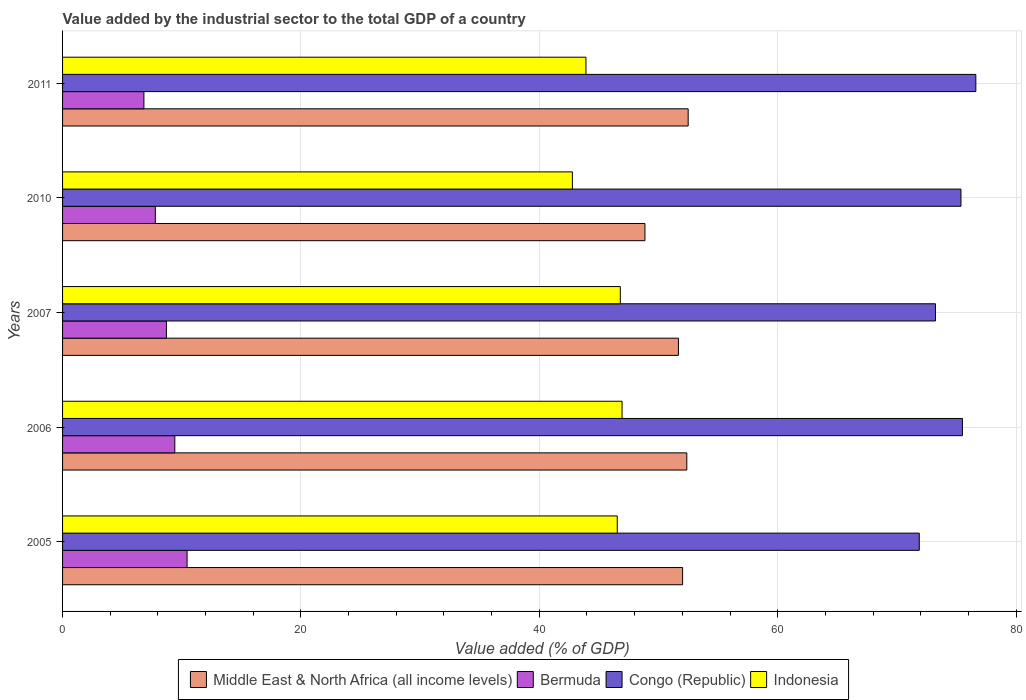How many different coloured bars are there?
Your answer should be compact. 4. How many bars are there on the 3rd tick from the top?
Your answer should be compact. 4. What is the label of the 5th group of bars from the top?
Your response must be concise. 2005. In how many cases, is the number of bars for a given year not equal to the number of legend labels?
Ensure brevity in your answer.  0. What is the value added by the industrial sector to the total GDP in Bermuda in 2006?
Provide a short and direct response. 9.42. Across all years, what is the maximum value added by the industrial sector to the total GDP in Indonesia?
Your answer should be compact. 46.94. Across all years, what is the minimum value added by the industrial sector to the total GDP in Indonesia?
Keep it short and to the point. 42.78. What is the total value added by the industrial sector to the total GDP in Middle East & North Africa (all income levels) in the graph?
Make the answer very short. 257.42. What is the difference between the value added by the industrial sector to the total GDP in Indonesia in 2005 and that in 2011?
Offer a very short reply. 2.63. What is the difference between the value added by the industrial sector to the total GDP in Middle East & North Africa (all income levels) in 2006 and the value added by the industrial sector to the total GDP in Indonesia in 2011?
Offer a very short reply. 8.46. What is the average value added by the industrial sector to the total GDP in Middle East & North Africa (all income levels) per year?
Keep it short and to the point. 51.48. In the year 2010, what is the difference between the value added by the industrial sector to the total GDP in Indonesia and value added by the industrial sector to the total GDP in Bermuda?
Ensure brevity in your answer.  34.99. In how many years, is the value added by the industrial sector to the total GDP in Congo (Republic) greater than 24 %?
Ensure brevity in your answer.  5. What is the ratio of the value added by the industrial sector to the total GDP in Bermuda in 2005 to that in 2007?
Your answer should be compact. 1.2. Is the difference between the value added by the industrial sector to the total GDP in Indonesia in 2006 and 2007 greater than the difference between the value added by the industrial sector to the total GDP in Bermuda in 2006 and 2007?
Your response must be concise. No. What is the difference between the highest and the second highest value added by the industrial sector to the total GDP in Indonesia?
Make the answer very short. 0.14. What is the difference between the highest and the lowest value added by the industrial sector to the total GDP in Middle East & North Africa (all income levels)?
Keep it short and to the point. 3.63. In how many years, is the value added by the industrial sector to the total GDP in Congo (Republic) greater than the average value added by the industrial sector to the total GDP in Congo (Republic) taken over all years?
Provide a succinct answer. 3. Is the sum of the value added by the industrial sector to the total GDP in Indonesia in 2007 and 2011 greater than the maximum value added by the industrial sector to the total GDP in Bermuda across all years?
Keep it short and to the point. Yes. Is it the case that in every year, the sum of the value added by the industrial sector to the total GDP in Bermuda and value added by the industrial sector to the total GDP in Congo (Republic) is greater than the sum of value added by the industrial sector to the total GDP in Middle East & North Africa (all income levels) and value added by the industrial sector to the total GDP in Indonesia?
Make the answer very short. Yes. What does the 3rd bar from the top in 2006 represents?
Offer a terse response. Bermuda. What does the 4th bar from the bottom in 2011 represents?
Make the answer very short. Indonesia. How many bars are there?
Offer a very short reply. 20. How many years are there in the graph?
Give a very brief answer. 5. What is the difference between two consecutive major ticks on the X-axis?
Ensure brevity in your answer.  20. Are the values on the major ticks of X-axis written in scientific E-notation?
Provide a short and direct response. No. How are the legend labels stacked?
Give a very brief answer. Horizontal. What is the title of the graph?
Offer a very short reply. Value added by the industrial sector to the total GDP of a country. What is the label or title of the X-axis?
Offer a terse response. Value added (% of GDP). What is the label or title of the Y-axis?
Provide a short and direct response. Years. What is the Value added (% of GDP) of Middle East & North Africa (all income levels) in 2005?
Provide a short and direct response. 52.02. What is the Value added (% of GDP) in Bermuda in 2005?
Ensure brevity in your answer.  10.45. What is the Value added (% of GDP) of Congo (Republic) in 2005?
Your answer should be compact. 71.88. What is the Value added (% of GDP) of Indonesia in 2005?
Keep it short and to the point. 46.54. What is the Value added (% of GDP) of Middle East & North Africa (all income levels) in 2006?
Keep it short and to the point. 52.37. What is the Value added (% of GDP) in Bermuda in 2006?
Offer a terse response. 9.42. What is the Value added (% of GDP) in Congo (Republic) in 2006?
Your response must be concise. 75.5. What is the Value added (% of GDP) in Indonesia in 2006?
Make the answer very short. 46.94. What is the Value added (% of GDP) in Middle East & North Africa (all income levels) in 2007?
Make the answer very short. 51.67. What is the Value added (% of GDP) in Bermuda in 2007?
Your answer should be compact. 8.71. What is the Value added (% of GDP) of Congo (Republic) in 2007?
Offer a terse response. 73.24. What is the Value added (% of GDP) in Indonesia in 2007?
Provide a succinct answer. 46.8. What is the Value added (% of GDP) in Middle East & North Africa (all income levels) in 2010?
Provide a short and direct response. 48.86. What is the Value added (% of GDP) in Bermuda in 2010?
Your response must be concise. 7.78. What is the Value added (% of GDP) of Congo (Republic) in 2010?
Give a very brief answer. 75.38. What is the Value added (% of GDP) in Indonesia in 2010?
Your response must be concise. 42.78. What is the Value added (% of GDP) of Middle East & North Africa (all income levels) in 2011?
Your answer should be compact. 52.49. What is the Value added (% of GDP) of Bermuda in 2011?
Provide a short and direct response. 6.83. What is the Value added (% of GDP) of Congo (Republic) in 2011?
Your response must be concise. 76.63. What is the Value added (% of GDP) in Indonesia in 2011?
Provide a succinct answer. 43.91. Across all years, what is the maximum Value added (% of GDP) of Middle East & North Africa (all income levels)?
Your answer should be very brief. 52.49. Across all years, what is the maximum Value added (% of GDP) of Bermuda?
Provide a short and direct response. 10.45. Across all years, what is the maximum Value added (% of GDP) in Congo (Republic)?
Keep it short and to the point. 76.63. Across all years, what is the maximum Value added (% of GDP) of Indonesia?
Ensure brevity in your answer.  46.94. Across all years, what is the minimum Value added (% of GDP) in Middle East & North Africa (all income levels)?
Offer a very short reply. 48.86. Across all years, what is the minimum Value added (% of GDP) in Bermuda?
Offer a very short reply. 6.83. Across all years, what is the minimum Value added (% of GDP) of Congo (Republic)?
Offer a very short reply. 71.88. Across all years, what is the minimum Value added (% of GDP) of Indonesia?
Keep it short and to the point. 42.78. What is the total Value added (% of GDP) of Middle East & North Africa (all income levels) in the graph?
Provide a short and direct response. 257.42. What is the total Value added (% of GDP) in Bermuda in the graph?
Offer a very short reply. 43.19. What is the total Value added (% of GDP) in Congo (Republic) in the graph?
Keep it short and to the point. 372.63. What is the total Value added (% of GDP) of Indonesia in the graph?
Provide a succinct answer. 226.97. What is the difference between the Value added (% of GDP) of Middle East & North Africa (all income levels) in 2005 and that in 2006?
Ensure brevity in your answer.  -0.35. What is the difference between the Value added (% of GDP) in Bermuda in 2005 and that in 2006?
Offer a very short reply. 1.03. What is the difference between the Value added (% of GDP) in Congo (Republic) in 2005 and that in 2006?
Make the answer very short. -3.62. What is the difference between the Value added (% of GDP) of Indonesia in 2005 and that in 2006?
Keep it short and to the point. -0.4. What is the difference between the Value added (% of GDP) in Middle East & North Africa (all income levels) in 2005 and that in 2007?
Offer a terse response. 0.35. What is the difference between the Value added (% of GDP) of Bermuda in 2005 and that in 2007?
Give a very brief answer. 1.74. What is the difference between the Value added (% of GDP) in Congo (Republic) in 2005 and that in 2007?
Your answer should be compact. -1.36. What is the difference between the Value added (% of GDP) of Indonesia in 2005 and that in 2007?
Provide a succinct answer. -0.26. What is the difference between the Value added (% of GDP) of Middle East & North Africa (all income levels) in 2005 and that in 2010?
Offer a terse response. 3.16. What is the difference between the Value added (% of GDP) of Bermuda in 2005 and that in 2010?
Provide a succinct answer. 2.67. What is the difference between the Value added (% of GDP) in Congo (Republic) in 2005 and that in 2010?
Provide a succinct answer. -3.5. What is the difference between the Value added (% of GDP) of Indonesia in 2005 and that in 2010?
Offer a terse response. 3.77. What is the difference between the Value added (% of GDP) in Middle East & North Africa (all income levels) in 2005 and that in 2011?
Give a very brief answer. -0.47. What is the difference between the Value added (% of GDP) of Bermuda in 2005 and that in 2011?
Give a very brief answer. 3.62. What is the difference between the Value added (% of GDP) in Congo (Republic) in 2005 and that in 2011?
Ensure brevity in your answer.  -4.74. What is the difference between the Value added (% of GDP) in Indonesia in 2005 and that in 2011?
Provide a succinct answer. 2.63. What is the difference between the Value added (% of GDP) in Middle East & North Africa (all income levels) in 2006 and that in 2007?
Your response must be concise. 0.7. What is the difference between the Value added (% of GDP) in Bermuda in 2006 and that in 2007?
Keep it short and to the point. 0.71. What is the difference between the Value added (% of GDP) in Congo (Republic) in 2006 and that in 2007?
Offer a very short reply. 2.26. What is the difference between the Value added (% of GDP) in Indonesia in 2006 and that in 2007?
Your response must be concise. 0.14. What is the difference between the Value added (% of GDP) of Middle East & North Africa (all income levels) in 2006 and that in 2010?
Your response must be concise. 3.51. What is the difference between the Value added (% of GDP) in Bermuda in 2006 and that in 2010?
Your response must be concise. 1.64. What is the difference between the Value added (% of GDP) of Congo (Republic) in 2006 and that in 2010?
Your response must be concise. 0.12. What is the difference between the Value added (% of GDP) of Indonesia in 2006 and that in 2010?
Provide a short and direct response. 4.17. What is the difference between the Value added (% of GDP) in Middle East & North Africa (all income levels) in 2006 and that in 2011?
Offer a terse response. -0.12. What is the difference between the Value added (% of GDP) of Bermuda in 2006 and that in 2011?
Offer a very short reply. 2.59. What is the difference between the Value added (% of GDP) of Congo (Republic) in 2006 and that in 2011?
Make the answer very short. -1.12. What is the difference between the Value added (% of GDP) of Indonesia in 2006 and that in 2011?
Provide a succinct answer. 3.03. What is the difference between the Value added (% of GDP) in Middle East & North Africa (all income levels) in 2007 and that in 2010?
Provide a succinct answer. 2.81. What is the difference between the Value added (% of GDP) of Bermuda in 2007 and that in 2010?
Offer a very short reply. 0.93. What is the difference between the Value added (% of GDP) in Congo (Republic) in 2007 and that in 2010?
Your answer should be compact. -2.14. What is the difference between the Value added (% of GDP) in Indonesia in 2007 and that in 2010?
Give a very brief answer. 4.02. What is the difference between the Value added (% of GDP) in Middle East & North Africa (all income levels) in 2007 and that in 2011?
Keep it short and to the point. -0.82. What is the difference between the Value added (% of GDP) in Bermuda in 2007 and that in 2011?
Your answer should be very brief. 1.89. What is the difference between the Value added (% of GDP) of Congo (Republic) in 2007 and that in 2011?
Your answer should be compact. -3.38. What is the difference between the Value added (% of GDP) of Indonesia in 2007 and that in 2011?
Your answer should be compact. 2.89. What is the difference between the Value added (% of GDP) of Middle East & North Africa (all income levels) in 2010 and that in 2011?
Offer a terse response. -3.63. What is the difference between the Value added (% of GDP) in Bermuda in 2010 and that in 2011?
Make the answer very short. 0.96. What is the difference between the Value added (% of GDP) of Congo (Republic) in 2010 and that in 2011?
Provide a succinct answer. -1.25. What is the difference between the Value added (% of GDP) of Indonesia in 2010 and that in 2011?
Provide a short and direct response. -1.14. What is the difference between the Value added (% of GDP) in Middle East & North Africa (all income levels) in 2005 and the Value added (% of GDP) in Bermuda in 2006?
Offer a very short reply. 42.6. What is the difference between the Value added (% of GDP) in Middle East & North Africa (all income levels) in 2005 and the Value added (% of GDP) in Congo (Republic) in 2006?
Offer a very short reply. -23.48. What is the difference between the Value added (% of GDP) of Middle East & North Africa (all income levels) in 2005 and the Value added (% of GDP) of Indonesia in 2006?
Your response must be concise. 5.08. What is the difference between the Value added (% of GDP) in Bermuda in 2005 and the Value added (% of GDP) in Congo (Republic) in 2006?
Provide a succinct answer. -65.05. What is the difference between the Value added (% of GDP) of Bermuda in 2005 and the Value added (% of GDP) of Indonesia in 2006?
Your answer should be very brief. -36.5. What is the difference between the Value added (% of GDP) in Congo (Republic) in 2005 and the Value added (% of GDP) in Indonesia in 2006?
Your answer should be compact. 24.94. What is the difference between the Value added (% of GDP) of Middle East & North Africa (all income levels) in 2005 and the Value added (% of GDP) of Bermuda in 2007?
Offer a terse response. 43.31. What is the difference between the Value added (% of GDP) in Middle East & North Africa (all income levels) in 2005 and the Value added (% of GDP) in Congo (Republic) in 2007?
Provide a short and direct response. -21.22. What is the difference between the Value added (% of GDP) in Middle East & North Africa (all income levels) in 2005 and the Value added (% of GDP) in Indonesia in 2007?
Provide a succinct answer. 5.22. What is the difference between the Value added (% of GDP) of Bermuda in 2005 and the Value added (% of GDP) of Congo (Republic) in 2007?
Keep it short and to the point. -62.79. What is the difference between the Value added (% of GDP) of Bermuda in 2005 and the Value added (% of GDP) of Indonesia in 2007?
Offer a terse response. -36.35. What is the difference between the Value added (% of GDP) of Congo (Republic) in 2005 and the Value added (% of GDP) of Indonesia in 2007?
Keep it short and to the point. 25.08. What is the difference between the Value added (% of GDP) of Middle East & North Africa (all income levels) in 2005 and the Value added (% of GDP) of Bermuda in 2010?
Offer a very short reply. 44.24. What is the difference between the Value added (% of GDP) of Middle East & North Africa (all income levels) in 2005 and the Value added (% of GDP) of Congo (Republic) in 2010?
Make the answer very short. -23.35. What is the difference between the Value added (% of GDP) in Middle East & North Africa (all income levels) in 2005 and the Value added (% of GDP) in Indonesia in 2010?
Provide a short and direct response. 9.25. What is the difference between the Value added (% of GDP) of Bermuda in 2005 and the Value added (% of GDP) of Congo (Republic) in 2010?
Your response must be concise. -64.93. What is the difference between the Value added (% of GDP) of Bermuda in 2005 and the Value added (% of GDP) of Indonesia in 2010?
Offer a very short reply. -32.33. What is the difference between the Value added (% of GDP) of Congo (Republic) in 2005 and the Value added (% of GDP) of Indonesia in 2010?
Your response must be concise. 29.11. What is the difference between the Value added (% of GDP) of Middle East & North Africa (all income levels) in 2005 and the Value added (% of GDP) of Bermuda in 2011?
Make the answer very short. 45.2. What is the difference between the Value added (% of GDP) in Middle East & North Africa (all income levels) in 2005 and the Value added (% of GDP) in Congo (Republic) in 2011?
Your answer should be very brief. -24.6. What is the difference between the Value added (% of GDP) of Middle East & North Africa (all income levels) in 2005 and the Value added (% of GDP) of Indonesia in 2011?
Offer a terse response. 8.11. What is the difference between the Value added (% of GDP) in Bermuda in 2005 and the Value added (% of GDP) in Congo (Republic) in 2011?
Give a very brief answer. -66.18. What is the difference between the Value added (% of GDP) in Bermuda in 2005 and the Value added (% of GDP) in Indonesia in 2011?
Your answer should be very brief. -33.47. What is the difference between the Value added (% of GDP) in Congo (Republic) in 2005 and the Value added (% of GDP) in Indonesia in 2011?
Make the answer very short. 27.97. What is the difference between the Value added (% of GDP) in Middle East & North Africa (all income levels) in 2006 and the Value added (% of GDP) in Bermuda in 2007?
Your answer should be very brief. 43.66. What is the difference between the Value added (% of GDP) of Middle East & North Africa (all income levels) in 2006 and the Value added (% of GDP) of Congo (Republic) in 2007?
Ensure brevity in your answer.  -20.87. What is the difference between the Value added (% of GDP) of Middle East & North Africa (all income levels) in 2006 and the Value added (% of GDP) of Indonesia in 2007?
Your response must be concise. 5.58. What is the difference between the Value added (% of GDP) of Bermuda in 2006 and the Value added (% of GDP) of Congo (Republic) in 2007?
Give a very brief answer. -63.82. What is the difference between the Value added (% of GDP) of Bermuda in 2006 and the Value added (% of GDP) of Indonesia in 2007?
Provide a succinct answer. -37.38. What is the difference between the Value added (% of GDP) in Congo (Republic) in 2006 and the Value added (% of GDP) in Indonesia in 2007?
Provide a short and direct response. 28.7. What is the difference between the Value added (% of GDP) in Middle East & North Africa (all income levels) in 2006 and the Value added (% of GDP) in Bermuda in 2010?
Your answer should be very brief. 44.59. What is the difference between the Value added (% of GDP) in Middle East & North Africa (all income levels) in 2006 and the Value added (% of GDP) in Congo (Republic) in 2010?
Ensure brevity in your answer.  -23. What is the difference between the Value added (% of GDP) in Middle East & North Africa (all income levels) in 2006 and the Value added (% of GDP) in Indonesia in 2010?
Ensure brevity in your answer.  9.6. What is the difference between the Value added (% of GDP) of Bermuda in 2006 and the Value added (% of GDP) of Congo (Republic) in 2010?
Keep it short and to the point. -65.96. What is the difference between the Value added (% of GDP) of Bermuda in 2006 and the Value added (% of GDP) of Indonesia in 2010?
Your response must be concise. -33.36. What is the difference between the Value added (% of GDP) in Congo (Republic) in 2006 and the Value added (% of GDP) in Indonesia in 2010?
Offer a terse response. 32.73. What is the difference between the Value added (% of GDP) of Middle East & North Africa (all income levels) in 2006 and the Value added (% of GDP) of Bermuda in 2011?
Ensure brevity in your answer.  45.55. What is the difference between the Value added (% of GDP) of Middle East & North Africa (all income levels) in 2006 and the Value added (% of GDP) of Congo (Republic) in 2011?
Keep it short and to the point. -24.25. What is the difference between the Value added (% of GDP) of Middle East & North Africa (all income levels) in 2006 and the Value added (% of GDP) of Indonesia in 2011?
Offer a terse response. 8.46. What is the difference between the Value added (% of GDP) in Bermuda in 2006 and the Value added (% of GDP) in Congo (Republic) in 2011?
Your answer should be very brief. -67.21. What is the difference between the Value added (% of GDP) in Bermuda in 2006 and the Value added (% of GDP) in Indonesia in 2011?
Provide a succinct answer. -34.5. What is the difference between the Value added (% of GDP) in Congo (Republic) in 2006 and the Value added (% of GDP) in Indonesia in 2011?
Offer a terse response. 31.59. What is the difference between the Value added (% of GDP) in Middle East & North Africa (all income levels) in 2007 and the Value added (% of GDP) in Bermuda in 2010?
Your response must be concise. 43.89. What is the difference between the Value added (% of GDP) in Middle East & North Africa (all income levels) in 2007 and the Value added (% of GDP) in Congo (Republic) in 2010?
Make the answer very short. -23.7. What is the difference between the Value added (% of GDP) in Middle East & North Africa (all income levels) in 2007 and the Value added (% of GDP) in Indonesia in 2010?
Your response must be concise. 8.9. What is the difference between the Value added (% of GDP) in Bermuda in 2007 and the Value added (% of GDP) in Congo (Republic) in 2010?
Offer a terse response. -66.66. What is the difference between the Value added (% of GDP) in Bermuda in 2007 and the Value added (% of GDP) in Indonesia in 2010?
Keep it short and to the point. -34.06. What is the difference between the Value added (% of GDP) in Congo (Republic) in 2007 and the Value added (% of GDP) in Indonesia in 2010?
Give a very brief answer. 30.46. What is the difference between the Value added (% of GDP) in Middle East & North Africa (all income levels) in 2007 and the Value added (% of GDP) in Bermuda in 2011?
Provide a succinct answer. 44.85. What is the difference between the Value added (% of GDP) in Middle East & North Africa (all income levels) in 2007 and the Value added (% of GDP) in Congo (Republic) in 2011?
Provide a succinct answer. -24.95. What is the difference between the Value added (% of GDP) in Middle East & North Africa (all income levels) in 2007 and the Value added (% of GDP) in Indonesia in 2011?
Offer a very short reply. 7.76. What is the difference between the Value added (% of GDP) in Bermuda in 2007 and the Value added (% of GDP) in Congo (Republic) in 2011?
Your answer should be compact. -67.91. What is the difference between the Value added (% of GDP) of Bermuda in 2007 and the Value added (% of GDP) of Indonesia in 2011?
Make the answer very short. -35.2. What is the difference between the Value added (% of GDP) in Congo (Republic) in 2007 and the Value added (% of GDP) in Indonesia in 2011?
Give a very brief answer. 29.33. What is the difference between the Value added (% of GDP) of Middle East & North Africa (all income levels) in 2010 and the Value added (% of GDP) of Bermuda in 2011?
Your answer should be very brief. 42.04. What is the difference between the Value added (% of GDP) in Middle East & North Africa (all income levels) in 2010 and the Value added (% of GDP) in Congo (Republic) in 2011?
Your response must be concise. -27.76. What is the difference between the Value added (% of GDP) in Middle East & North Africa (all income levels) in 2010 and the Value added (% of GDP) in Indonesia in 2011?
Ensure brevity in your answer.  4.95. What is the difference between the Value added (% of GDP) of Bermuda in 2010 and the Value added (% of GDP) of Congo (Republic) in 2011?
Make the answer very short. -68.84. What is the difference between the Value added (% of GDP) of Bermuda in 2010 and the Value added (% of GDP) of Indonesia in 2011?
Offer a terse response. -36.13. What is the difference between the Value added (% of GDP) in Congo (Republic) in 2010 and the Value added (% of GDP) in Indonesia in 2011?
Keep it short and to the point. 31.46. What is the average Value added (% of GDP) of Middle East & North Africa (all income levels) per year?
Offer a very short reply. 51.48. What is the average Value added (% of GDP) in Bermuda per year?
Your answer should be compact. 8.64. What is the average Value added (% of GDP) in Congo (Republic) per year?
Provide a short and direct response. 74.53. What is the average Value added (% of GDP) of Indonesia per year?
Ensure brevity in your answer.  45.39. In the year 2005, what is the difference between the Value added (% of GDP) in Middle East & North Africa (all income levels) and Value added (% of GDP) in Bermuda?
Your answer should be very brief. 41.58. In the year 2005, what is the difference between the Value added (% of GDP) in Middle East & North Africa (all income levels) and Value added (% of GDP) in Congo (Republic)?
Your answer should be compact. -19.86. In the year 2005, what is the difference between the Value added (% of GDP) in Middle East & North Africa (all income levels) and Value added (% of GDP) in Indonesia?
Your answer should be compact. 5.48. In the year 2005, what is the difference between the Value added (% of GDP) in Bermuda and Value added (% of GDP) in Congo (Republic)?
Offer a very short reply. -61.43. In the year 2005, what is the difference between the Value added (% of GDP) in Bermuda and Value added (% of GDP) in Indonesia?
Provide a succinct answer. -36.09. In the year 2005, what is the difference between the Value added (% of GDP) in Congo (Republic) and Value added (% of GDP) in Indonesia?
Make the answer very short. 25.34. In the year 2006, what is the difference between the Value added (% of GDP) of Middle East & North Africa (all income levels) and Value added (% of GDP) of Bermuda?
Offer a very short reply. 42.96. In the year 2006, what is the difference between the Value added (% of GDP) of Middle East & North Africa (all income levels) and Value added (% of GDP) of Congo (Republic)?
Make the answer very short. -23.13. In the year 2006, what is the difference between the Value added (% of GDP) of Middle East & North Africa (all income levels) and Value added (% of GDP) of Indonesia?
Provide a succinct answer. 5.43. In the year 2006, what is the difference between the Value added (% of GDP) of Bermuda and Value added (% of GDP) of Congo (Republic)?
Your answer should be very brief. -66.08. In the year 2006, what is the difference between the Value added (% of GDP) of Bermuda and Value added (% of GDP) of Indonesia?
Offer a very short reply. -37.53. In the year 2006, what is the difference between the Value added (% of GDP) in Congo (Republic) and Value added (% of GDP) in Indonesia?
Your answer should be compact. 28.56. In the year 2007, what is the difference between the Value added (% of GDP) of Middle East & North Africa (all income levels) and Value added (% of GDP) of Bermuda?
Your response must be concise. 42.96. In the year 2007, what is the difference between the Value added (% of GDP) of Middle East & North Africa (all income levels) and Value added (% of GDP) of Congo (Republic)?
Offer a terse response. -21.57. In the year 2007, what is the difference between the Value added (% of GDP) of Middle East & North Africa (all income levels) and Value added (% of GDP) of Indonesia?
Provide a short and direct response. 4.87. In the year 2007, what is the difference between the Value added (% of GDP) of Bermuda and Value added (% of GDP) of Congo (Republic)?
Ensure brevity in your answer.  -64.53. In the year 2007, what is the difference between the Value added (% of GDP) of Bermuda and Value added (% of GDP) of Indonesia?
Give a very brief answer. -38.09. In the year 2007, what is the difference between the Value added (% of GDP) of Congo (Republic) and Value added (% of GDP) of Indonesia?
Ensure brevity in your answer.  26.44. In the year 2010, what is the difference between the Value added (% of GDP) in Middle East & North Africa (all income levels) and Value added (% of GDP) in Bermuda?
Offer a terse response. 41.08. In the year 2010, what is the difference between the Value added (% of GDP) of Middle East & North Africa (all income levels) and Value added (% of GDP) of Congo (Republic)?
Offer a very short reply. -26.51. In the year 2010, what is the difference between the Value added (% of GDP) of Middle East & North Africa (all income levels) and Value added (% of GDP) of Indonesia?
Offer a terse response. 6.09. In the year 2010, what is the difference between the Value added (% of GDP) of Bermuda and Value added (% of GDP) of Congo (Republic)?
Provide a short and direct response. -67.59. In the year 2010, what is the difference between the Value added (% of GDP) in Bermuda and Value added (% of GDP) in Indonesia?
Your answer should be very brief. -34.99. In the year 2010, what is the difference between the Value added (% of GDP) of Congo (Republic) and Value added (% of GDP) of Indonesia?
Provide a short and direct response. 32.6. In the year 2011, what is the difference between the Value added (% of GDP) of Middle East & North Africa (all income levels) and Value added (% of GDP) of Bermuda?
Offer a very short reply. 45.66. In the year 2011, what is the difference between the Value added (% of GDP) of Middle East & North Africa (all income levels) and Value added (% of GDP) of Congo (Republic)?
Offer a very short reply. -24.14. In the year 2011, what is the difference between the Value added (% of GDP) of Middle East & North Africa (all income levels) and Value added (% of GDP) of Indonesia?
Make the answer very short. 8.58. In the year 2011, what is the difference between the Value added (% of GDP) in Bermuda and Value added (% of GDP) in Congo (Republic)?
Your answer should be compact. -69.8. In the year 2011, what is the difference between the Value added (% of GDP) in Bermuda and Value added (% of GDP) in Indonesia?
Your answer should be very brief. -37.09. In the year 2011, what is the difference between the Value added (% of GDP) in Congo (Republic) and Value added (% of GDP) in Indonesia?
Your answer should be very brief. 32.71. What is the ratio of the Value added (% of GDP) in Middle East & North Africa (all income levels) in 2005 to that in 2006?
Your answer should be very brief. 0.99. What is the ratio of the Value added (% of GDP) of Bermuda in 2005 to that in 2006?
Your answer should be very brief. 1.11. What is the ratio of the Value added (% of GDP) of Congo (Republic) in 2005 to that in 2006?
Provide a succinct answer. 0.95. What is the ratio of the Value added (% of GDP) of Indonesia in 2005 to that in 2006?
Your answer should be very brief. 0.99. What is the ratio of the Value added (% of GDP) in Middle East & North Africa (all income levels) in 2005 to that in 2007?
Offer a very short reply. 1.01. What is the ratio of the Value added (% of GDP) of Bermuda in 2005 to that in 2007?
Offer a terse response. 1.2. What is the ratio of the Value added (% of GDP) in Congo (Republic) in 2005 to that in 2007?
Offer a terse response. 0.98. What is the ratio of the Value added (% of GDP) of Indonesia in 2005 to that in 2007?
Ensure brevity in your answer.  0.99. What is the ratio of the Value added (% of GDP) of Middle East & North Africa (all income levels) in 2005 to that in 2010?
Offer a very short reply. 1.06. What is the ratio of the Value added (% of GDP) of Bermuda in 2005 to that in 2010?
Your answer should be compact. 1.34. What is the ratio of the Value added (% of GDP) of Congo (Republic) in 2005 to that in 2010?
Provide a succinct answer. 0.95. What is the ratio of the Value added (% of GDP) of Indonesia in 2005 to that in 2010?
Keep it short and to the point. 1.09. What is the ratio of the Value added (% of GDP) of Middle East & North Africa (all income levels) in 2005 to that in 2011?
Keep it short and to the point. 0.99. What is the ratio of the Value added (% of GDP) in Bermuda in 2005 to that in 2011?
Keep it short and to the point. 1.53. What is the ratio of the Value added (% of GDP) of Congo (Republic) in 2005 to that in 2011?
Ensure brevity in your answer.  0.94. What is the ratio of the Value added (% of GDP) of Indonesia in 2005 to that in 2011?
Offer a terse response. 1.06. What is the ratio of the Value added (% of GDP) of Middle East & North Africa (all income levels) in 2006 to that in 2007?
Provide a short and direct response. 1.01. What is the ratio of the Value added (% of GDP) of Bermuda in 2006 to that in 2007?
Make the answer very short. 1.08. What is the ratio of the Value added (% of GDP) in Congo (Republic) in 2006 to that in 2007?
Make the answer very short. 1.03. What is the ratio of the Value added (% of GDP) of Indonesia in 2006 to that in 2007?
Keep it short and to the point. 1. What is the ratio of the Value added (% of GDP) of Middle East & North Africa (all income levels) in 2006 to that in 2010?
Make the answer very short. 1.07. What is the ratio of the Value added (% of GDP) in Bermuda in 2006 to that in 2010?
Your response must be concise. 1.21. What is the ratio of the Value added (% of GDP) in Congo (Republic) in 2006 to that in 2010?
Keep it short and to the point. 1. What is the ratio of the Value added (% of GDP) of Indonesia in 2006 to that in 2010?
Offer a very short reply. 1.1. What is the ratio of the Value added (% of GDP) in Bermuda in 2006 to that in 2011?
Make the answer very short. 1.38. What is the ratio of the Value added (% of GDP) of Indonesia in 2006 to that in 2011?
Your answer should be very brief. 1.07. What is the ratio of the Value added (% of GDP) in Middle East & North Africa (all income levels) in 2007 to that in 2010?
Your answer should be very brief. 1.06. What is the ratio of the Value added (% of GDP) of Bermuda in 2007 to that in 2010?
Make the answer very short. 1.12. What is the ratio of the Value added (% of GDP) of Congo (Republic) in 2007 to that in 2010?
Give a very brief answer. 0.97. What is the ratio of the Value added (% of GDP) of Indonesia in 2007 to that in 2010?
Give a very brief answer. 1.09. What is the ratio of the Value added (% of GDP) of Middle East & North Africa (all income levels) in 2007 to that in 2011?
Provide a succinct answer. 0.98. What is the ratio of the Value added (% of GDP) of Bermuda in 2007 to that in 2011?
Offer a terse response. 1.28. What is the ratio of the Value added (% of GDP) in Congo (Republic) in 2007 to that in 2011?
Your response must be concise. 0.96. What is the ratio of the Value added (% of GDP) in Indonesia in 2007 to that in 2011?
Your response must be concise. 1.07. What is the ratio of the Value added (% of GDP) of Middle East & North Africa (all income levels) in 2010 to that in 2011?
Keep it short and to the point. 0.93. What is the ratio of the Value added (% of GDP) in Bermuda in 2010 to that in 2011?
Your response must be concise. 1.14. What is the ratio of the Value added (% of GDP) of Congo (Republic) in 2010 to that in 2011?
Your response must be concise. 0.98. What is the ratio of the Value added (% of GDP) of Indonesia in 2010 to that in 2011?
Offer a very short reply. 0.97. What is the difference between the highest and the second highest Value added (% of GDP) in Middle East & North Africa (all income levels)?
Your response must be concise. 0.12. What is the difference between the highest and the second highest Value added (% of GDP) of Bermuda?
Keep it short and to the point. 1.03. What is the difference between the highest and the second highest Value added (% of GDP) of Congo (Republic)?
Your answer should be compact. 1.12. What is the difference between the highest and the second highest Value added (% of GDP) in Indonesia?
Ensure brevity in your answer.  0.14. What is the difference between the highest and the lowest Value added (% of GDP) of Middle East & North Africa (all income levels)?
Offer a terse response. 3.63. What is the difference between the highest and the lowest Value added (% of GDP) of Bermuda?
Provide a short and direct response. 3.62. What is the difference between the highest and the lowest Value added (% of GDP) of Congo (Republic)?
Provide a short and direct response. 4.74. What is the difference between the highest and the lowest Value added (% of GDP) of Indonesia?
Your response must be concise. 4.17. 